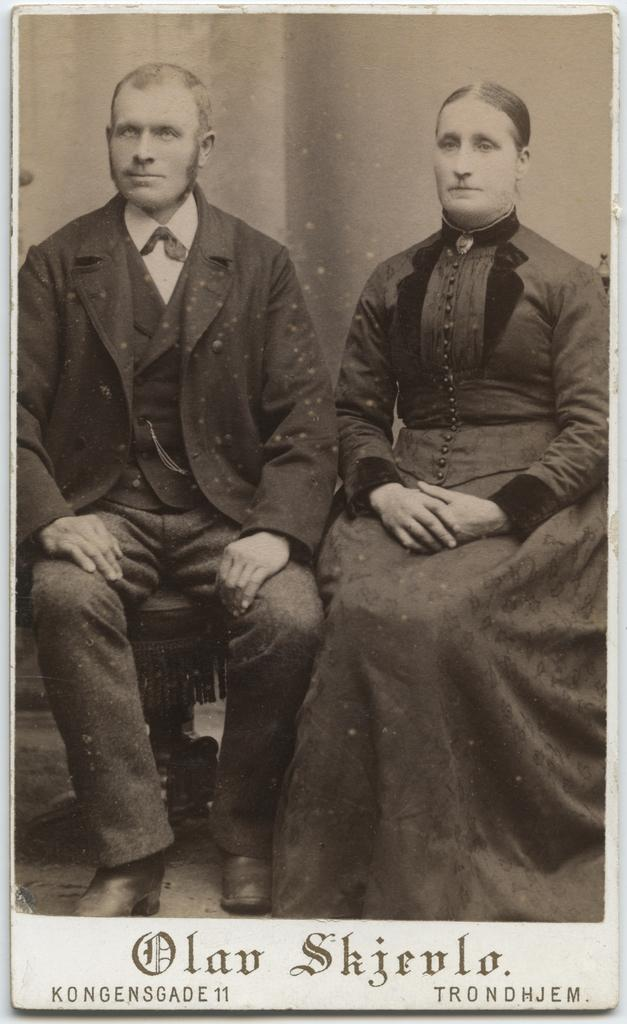What is the color scheme of the picture? The picture is black and white. How many people are in the picture? There are two people sitting in the picture. Is there any text present in the image? Yes, there is text written at the bottom of the picture. What type of garden can be seen in the background of the picture? There is no garden visible in the picture, as it is a black and white image with two people sitting and text at the bottom. 